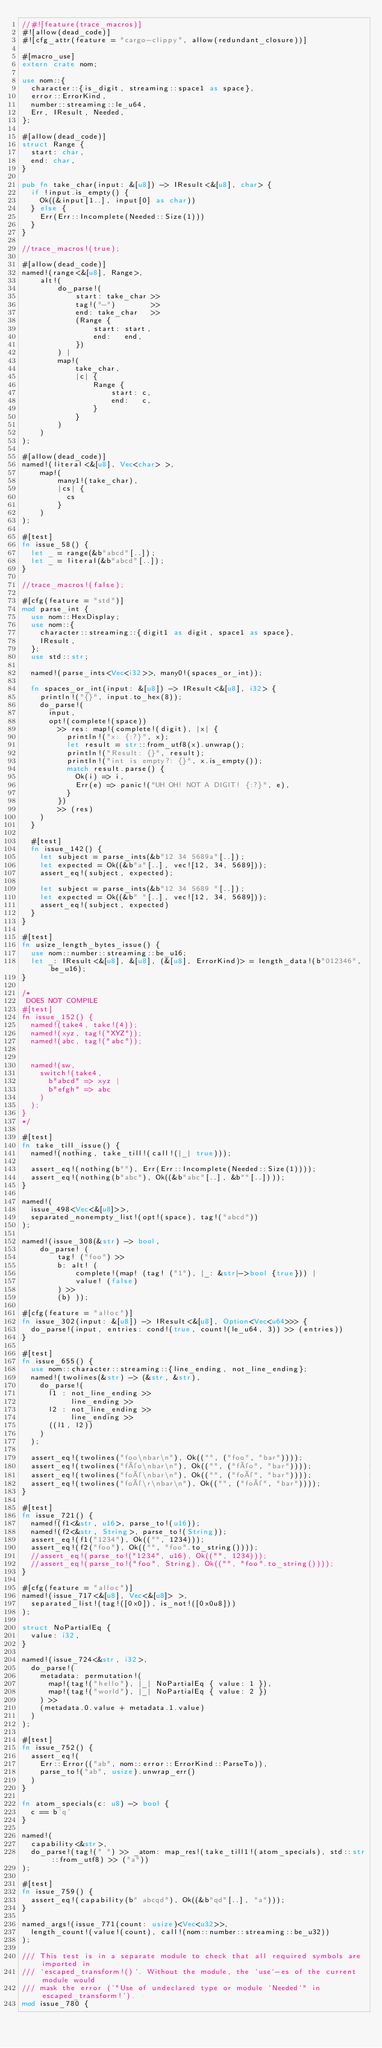<code> <loc_0><loc_0><loc_500><loc_500><_Rust_>//#![feature(trace_macros)]
#![allow(dead_code)]
#![cfg_attr(feature = "cargo-clippy", allow(redundant_closure))]

#[macro_use]
extern crate nom;

use nom::{
  character::{is_digit, streaming::space1 as space},
  error::ErrorKind,
  number::streaming::le_u64,
  Err, IResult, Needed,
};

#[allow(dead_code)]
struct Range {
  start: char,
  end: char,
}

pub fn take_char(input: &[u8]) -> IResult<&[u8], char> {
  if !input.is_empty() {
    Ok((&input[1..], input[0] as char))
  } else {
    Err(Err::Incomplete(Needed::Size(1)))
  }
}

//trace_macros!(true);

#[allow(dead_code)]
named!(range<&[u8], Range>,
    alt!(
        do_parse!(
            start: take_char >>
            tag!("-")        >>
            end: take_char   >>
            (Range {
                start: start,
                end:   end,
            })
        ) |
        map!(
            take_char,
            |c| {
                Range {
                    start: c,
                    end:   c,
                }
            }
        )
    )
);

#[allow(dead_code)]
named!(literal<&[u8], Vec<char> >,
    map!(
        many1!(take_char),
        |cs| {
          cs
        }
    )
);

#[test]
fn issue_58() {
  let _ = range(&b"abcd"[..]);
  let _ = literal(&b"abcd"[..]);
}

//trace_macros!(false);

#[cfg(feature = "std")]
mod parse_int {
  use nom::HexDisplay;
  use nom::{
    character::streaming::{digit1 as digit, space1 as space},
    IResult,
  };
  use std::str;

  named!(parse_ints<Vec<i32>>, many0!(spaces_or_int));

  fn spaces_or_int(input: &[u8]) -> IResult<&[u8], i32> {
    println!("{}", input.to_hex(8));
    do_parse!(
      input,
      opt!(complete!(space))
        >> res: map!(complete!(digit), |x| {
          println!("x: {:?}", x);
          let result = str::from_utf8(x).unwrap();
          println!("Result: {}", result);
          println!("int is empty?: {}", x.is_empty());
          match result.parse() {
            Ok(i) => i,
            Err(e) => panic!("UH OH! NOT A DIGIT! {:?}", e),
          }
        })
        >> (res)
    )
  }

  #[test]
  fn issue_142() {
    let subject = parse_ints(&b"12 34 5689a"[..]);
    let expected = Ok((&b"a"[..], vec![12, 34, 5689]));
    assert_eq!(subject, expected);

    let subject = parse_ints(&b"12 34 5689 "[..]);
    let expected = Ok((&b" "[..], vec![12, 34, 5689]));
    assert_eq!(subject, expected)
  }
}

#[test]
fn usize_length_bytes_issue() {
  use nom::number::streaming::be_u16;
  let _: IResult<&[u8], &[u8], (&[u8], ErrorKind)> = length_data!(b"012346", be_u16);
}

/*
 DOES NOT COMPILE
#[test]
fn issue_152() {
  named!(take4, take!(4));
  named!(xyz, tag!("XYZ"));
  named!(abc, tag!("abc"));


  named!(sw,
    switch!(take4,
      b"abcd" => xyz |
      b"efgh" => abc
    )
  );
}
*/

#[test]
fn take_till_issue() {
  named!(nothing, take_till!(call!(|_| true)));

  assert_eq!(nothing(b""), Err(Err::Incomplete(Needed::Size(1))));
  assert_eq!(nothing(b"abc"), Ok((&b"abc"[..], &b""[..])));
}

named!(
  issue_498<Vec<&[u8]>>,
  separated_nonempty_list!(opt!(space), tag!("abcd"))
);

named!(issue_308(&str) -> bool,
    do_parse! (
        tag! ("foo") >>
        b: alt! (
            complete!(map! (tag! ("1"), |_: &str|->bool {true})) |
            value! (false)
        ) >>
        (b) ));

#[cfg(feature = "alloc")]
fn issue_302(input: &[u8]) -> IResult<&[u8], Option<Vec<u64>>> {
  do_parse!(input, entries: cond!(true, count!(le_u64, 3)) >> (entries))
}

#[test]
fn issue_655() {
  use nom::character::streaming::{line_ending, not_line_ending};
  named!(twolines(&str) -> (&str, &str),
    do_parse!(
      l1 : not_line_ending >>
           line_ending >>
      l2 : not_line_ending >>
           line_ending >>
      ((l1, l2))
    )
  );

  assert_eq!(twolines("foo\nbar\n"), Ok(("", ("foo", "bar"))));
  assert_eq!(twolines("féo\nbar\n"), Ok(("", ("féo", "bar"))));
  assert_eq!(twolines("foé\nbar\n"), Ok(("", ("foé", "bar"))));
  assert_eq!(twolines("foé\r\nbar\n"), Ok(("", ("foé", "bar"))));
}

#[test]
fn issue_721() {
  named!(f1<&str, u16>, parse_to!(u16));
  named!(f2<&str, String>, parse_to!(String));
  assert_eq!(f1("1234"), Ok(("", 1234)));
  assert_eq!(f2("foo"), Ok(("", "foo".to_string())));
  //assert_eq!(parse_to!("1234", u16), Ok(("", 1234)));
  //assert_eq!(parse_to!("foo", String), Ok(("", "foo".to_string())));
}

#[cfg(feature = "alloc")]
named!(issue_717<&[u8], Vec<&[u8]> >,
  separated_list!(tag!([0x0]), is_not!([0x0u8]))
);

struct NoPartialEq {
  value: i32,
}

named!(issue_724<&str, i32>,
  do_parse!(
    metadata: permutation!(
      map!(tag!("hello"), |_| NoPartialEq { value: 1 }),
      map!(tag!("world"), |_| NoPartialEq { value: 2 })
    ) >>
    (metadata.0.value + metadata.1.value)
  )
);

#[test]
fn issue_752() {
  assert_eq!(
    Err::Error(("ab", nom::error::ErrorKind::ParseTo)),
    parse_to!("ab", usize).unwrap_err()
  )
}

fn atom_specials(c: u8) -> bool {
  c == b'q'
}

named!(
  capability<&str>,
  do_parse!(tag!(" ") >> _atom: map_res!(take_till1!(atom_specials), std::str::from_utf8) >> ("a"))
);

#[test]
fn issue_759() {
  assert_eq!(capability(b" abcqd"), Ok((&b"qd"[..], "a")));
}

named_args!(issue_771(count: usize)<Vec<u32>>,
  length_count!(value!(count), call!(nom::number::streaming::be_u32))
);

/// This test is in a separate module to check that all required symbols are imported in
/// `escaped_transform!()`. Without the module, the `use`-es of the current module would
/// mask the error ('"Use of undeclared type or module `Needed`" in escaped_transform!').
mod issue_780 {</code> 